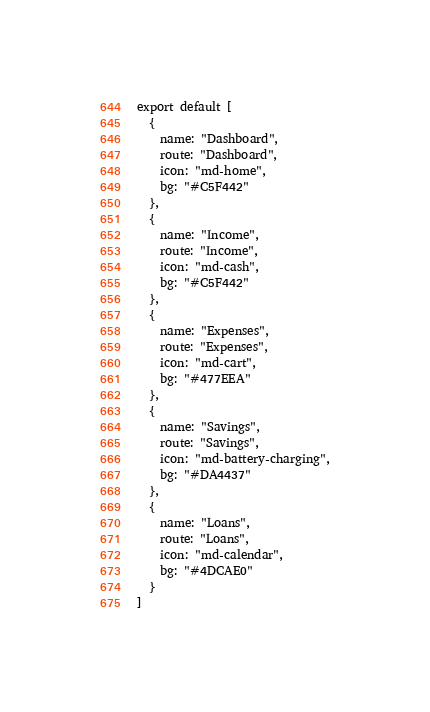Convert code to text. <code><loc_0><loc_0><loc_500><loc_500><_JavaScript_>export default [
  {
    name: "Dashboard",
    route: "Dashboard",
    icon: "md-home",
    bg: "#C5F442"
  },
  {
    name: "Income",
    route: "Income",
    icon: "md-cash",
    bg: "#C5F442"
  },
  {
    name: "Expenses",
    route: "Expenses",
    icon: "md-cart",
    bg: "#477EEA"
  },
  {
    name: "Savings",
    route: "Savings",
    icon: "md-battery-charging",
    bg: "#DA4437"
  },
  {
    name: "Loans",
    route: "Loans",
    icon: "md-calendar",
    bg: "#4DCAE0"
  }
]
</code> 